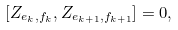Convert formula to latex. <formula><loc_0><loc_0><loc_500><loc_500>[ Z _ { e _ { k } , f _ { k } } , Z _ { e _ { k + 1 } , f _ { k + 1 } } ] = 0 ,</formula> 